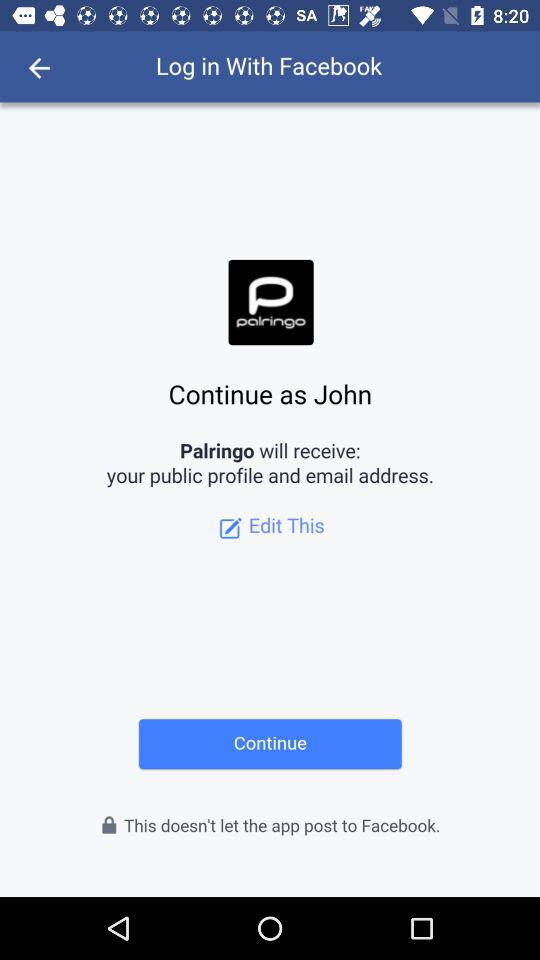What is the name of the user? The name of the user is "John". 